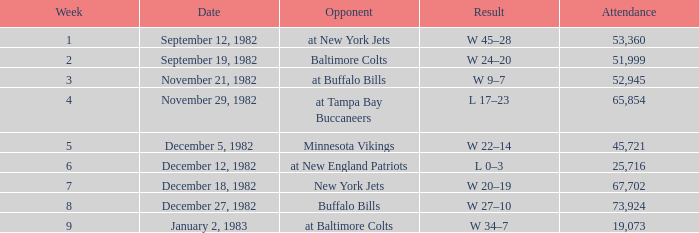What is the outcome of the game with a turnout exceeding 67,702? W 27–10. 